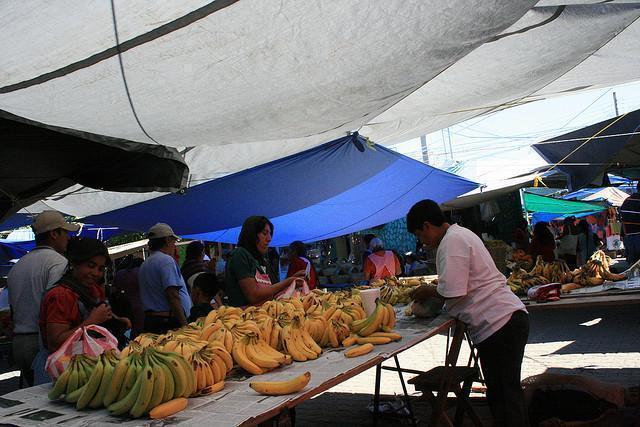Encouraging what American Ice cream treat is an obvious choice for these vendors?
Select the accurate response from the four choices given to answer the question.
Options: Banana split, chocolate malt, chocolate sundae, brownie cake. Banana split. 